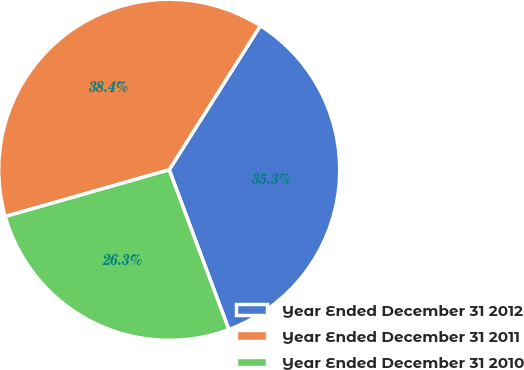<chart> <loc_0><loc_0><loc_500><loc_500><pie_chart><fcel>Year Ended December 31 2012<fcel>Year Ended December 31 2011<fcel>Year Ended December 31 2010<nl><fcel>35.34%<fcel>38.4%<fcel>26.27%<nl></chart> 